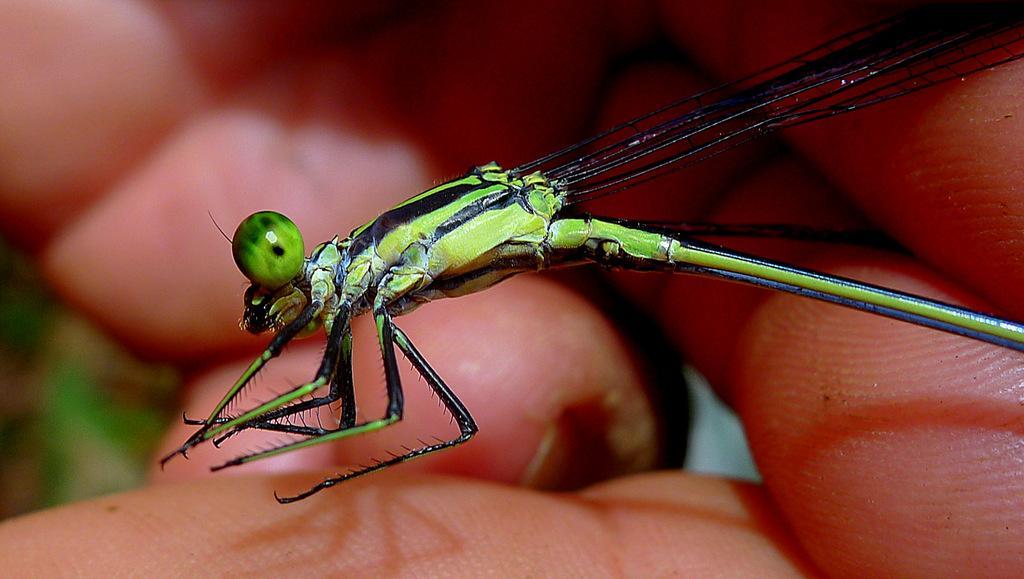Describe this image in one or two sentences. In this image I can see a person's hand and a butterfly. This image is taken during a day. 